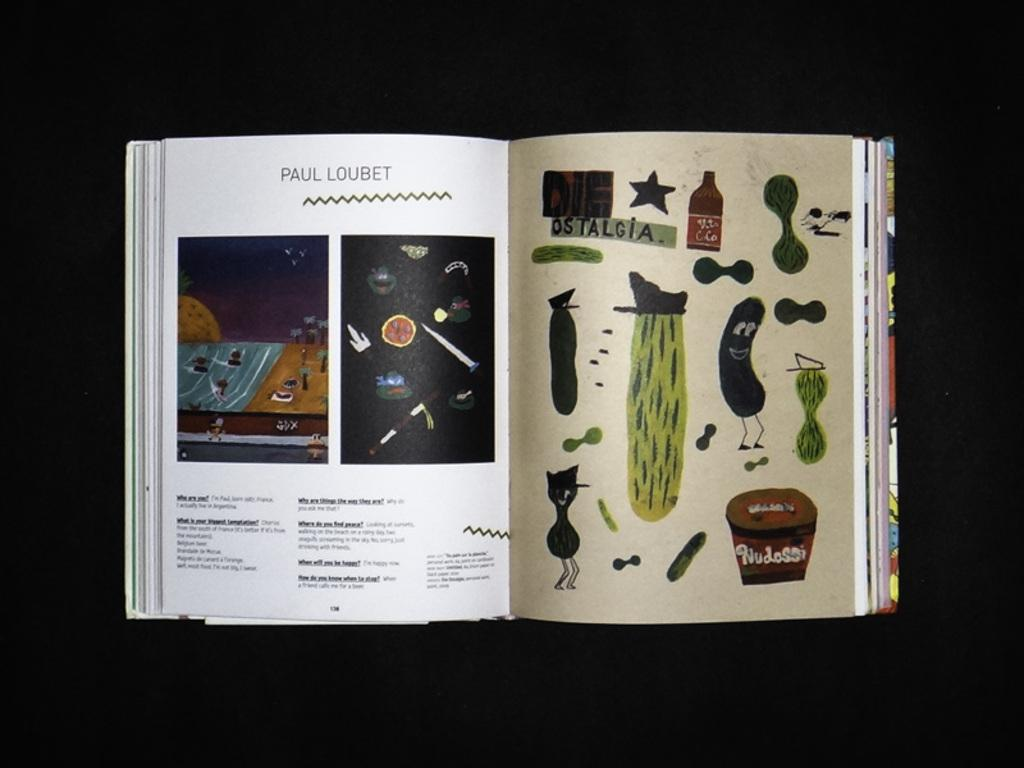What is the main object in the image? There is an open book in the image. What can be found inside the open book? The open book contains images and text. Can you describe the type of images in the open book? There is cartoon art in the open book. What type of animal can be seen in the arch on the cover of the open book? There is no arch or animal present on the cover of the open book; it contains cartoon art within its pages. 